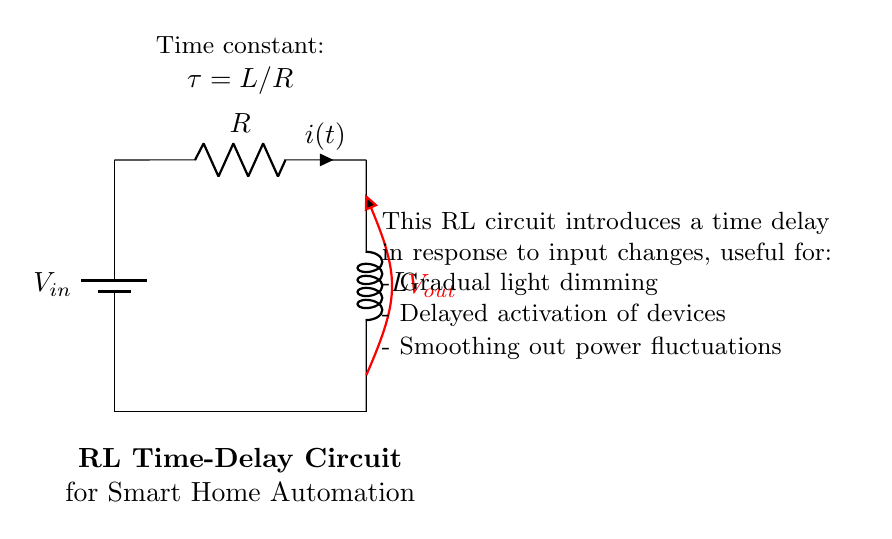What are the components in the circuit? The circuit consists of a battery, a resistor, and an inductor as labeled. The battery supplies voltage, the resistor limits current, and the inductor stores energy in a magnetic field.
Answer: battery, resistor, inductor What is the value of the time constant in the circuit? The time constant is given by the formula tau equals L divided by R. This indicates how quickly the circuit responds to changes in voltage or current.
Answer: L/R What is the function of the inductor in this circuit? The inductor in this circuit is responsible for storing energy and providing a time delay in the current response, smoothing changes over time rather than allowing immediate spikes.
Answer: time delay What does V out represent in the circuit? V out is the output voltage across the inductor, representing the voltage that will be observed after the time delay caused by the inductor when the circuit is activated.
Answer: output voltage How does the configuration impact smart home automation? The RL circuit configuration allows for gradual activation and deactivation of smart home devices, preventing abrupt changes that may disrupt operations, like sudden light changes or device activations.
Answer: gradual activation What happens to the current when the input voltage is applied? When the input voltage is applied, the current starts to increase gradually rather than instantaneously, due to the presence of the inductor, which resists changes in current flow.
Answer: current increase What applications could benefit from this RL time-delay circuit? This type of circuit could be useful for applications like gradual light dimming, delayed start for appliances, and filtering power supply fluctuations in smart home systems.
Answer: smart home devices 